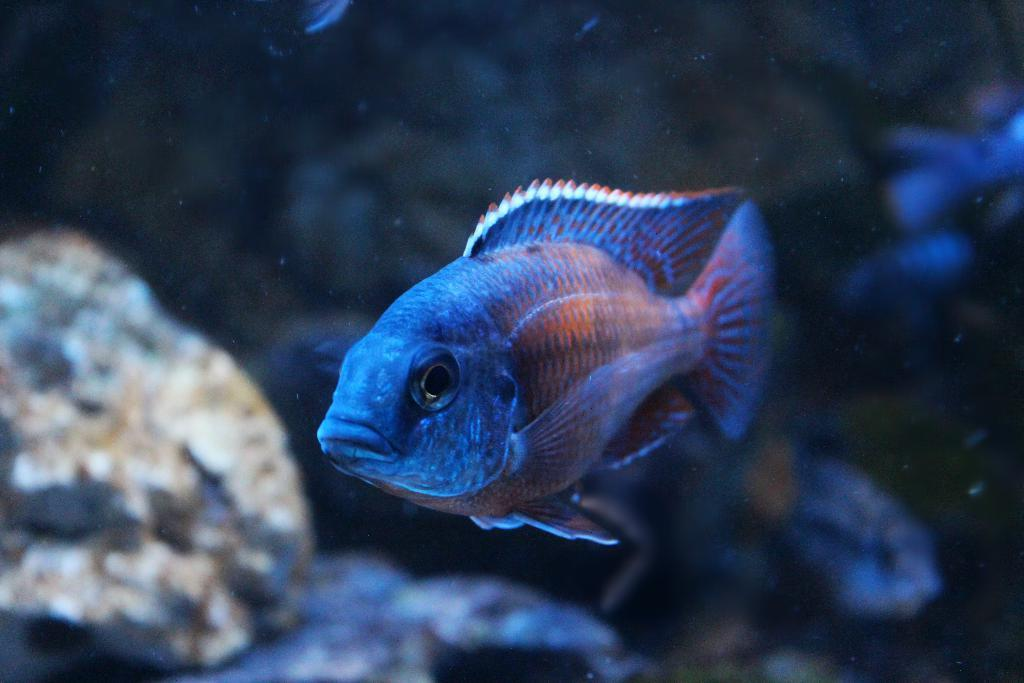What type of animal can be seen in the water in the image? There is a fish in the water in the image. What can be seen on the left side of the image? There are rocks on the left side of the image. Is there a question mark visible in the image? There is no reference to a question mark in the image; it only features a fish in the water and rocks on the left side. 